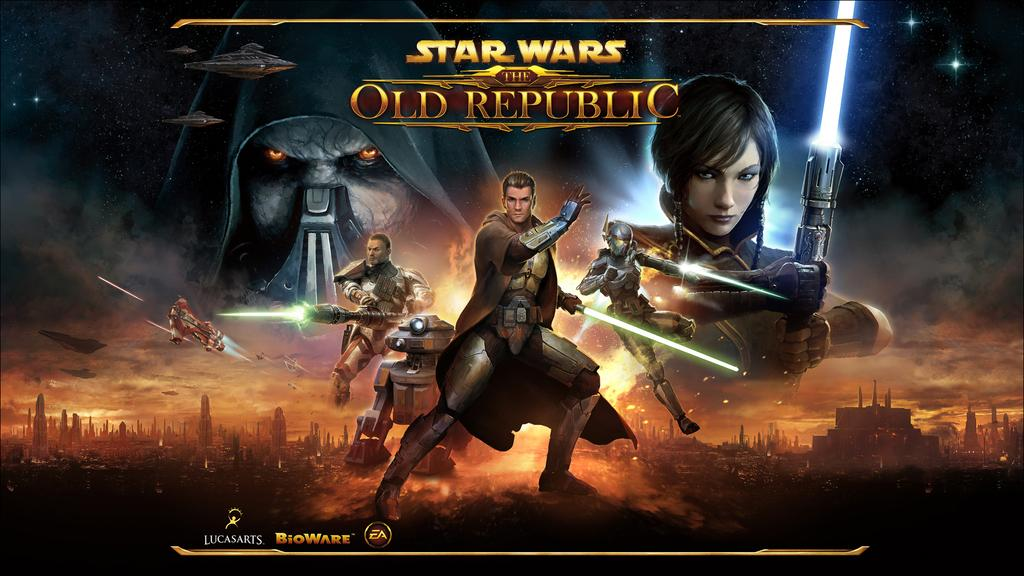<image>
Write a terse but informative summary of the picture. An advertisement for the Star Wars movie The Old Republic. 